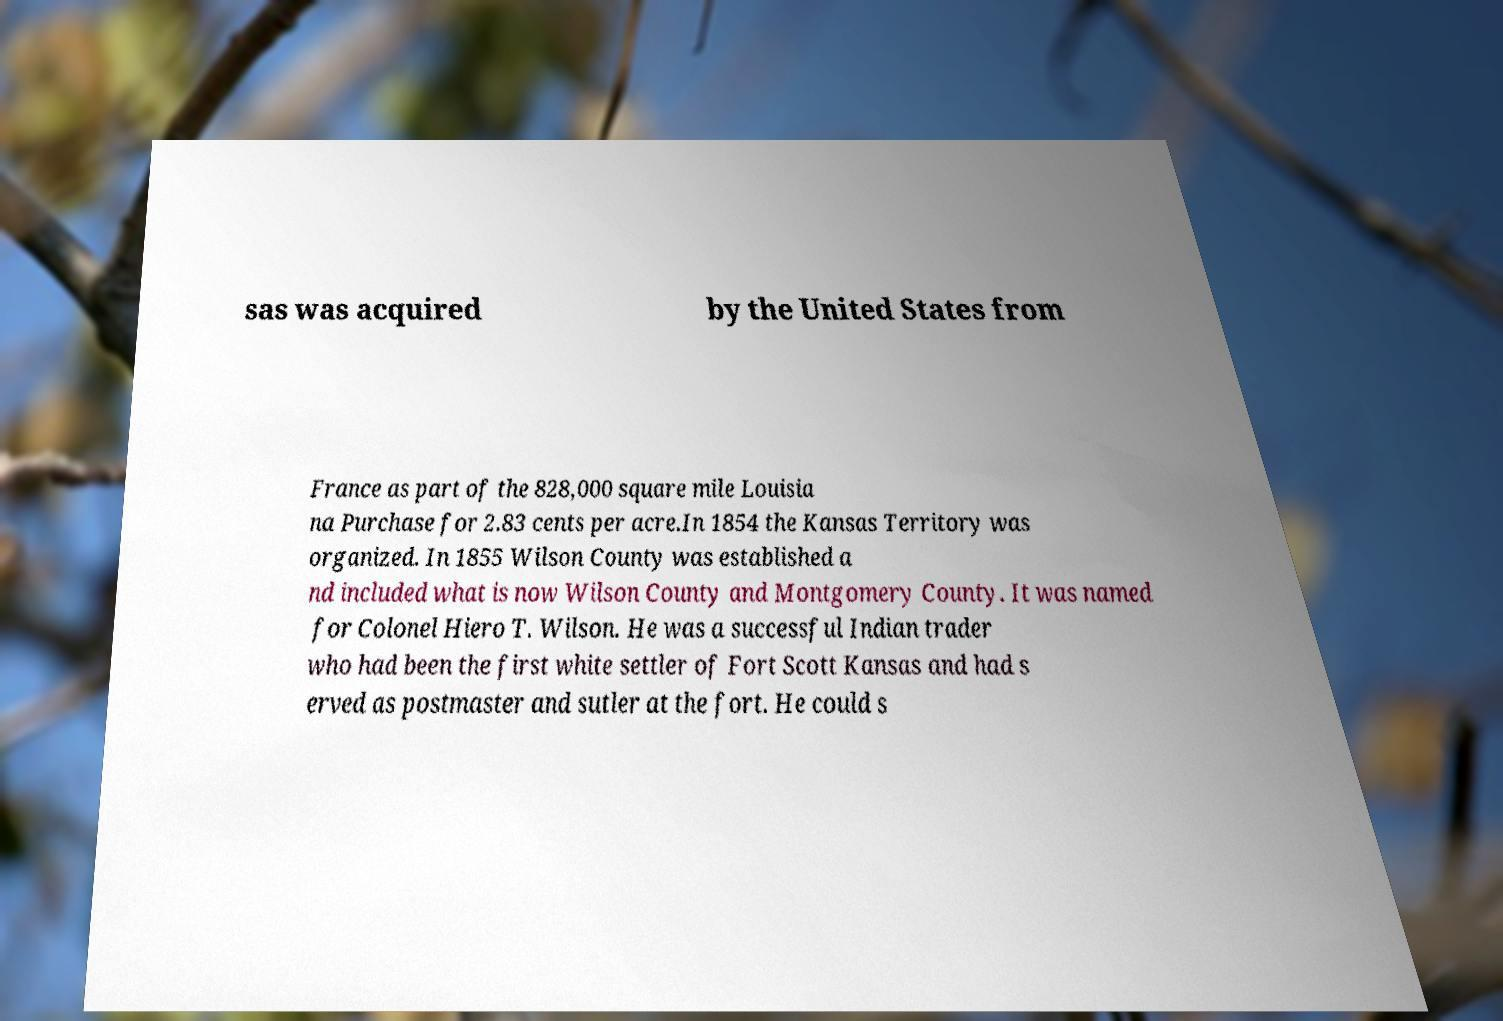For documentation purposes, I need the text within this image transcribed. Could you provide that? sas was acquired by the United States from France as part of the 828,000 square mile Louisia na Purchase for 2.83 cents per acre.In 1854 the Kansas Territory was organized. In 1855 Wilson County was established a nd included what is now Wilson County and Montgomery County. It was named for Colonel Hiero T. Wilson. He was a successful Indian trader who had been the first white settler of Fort Scott Kansas and had s erved as postmaster and sutler at the fort. He could s 